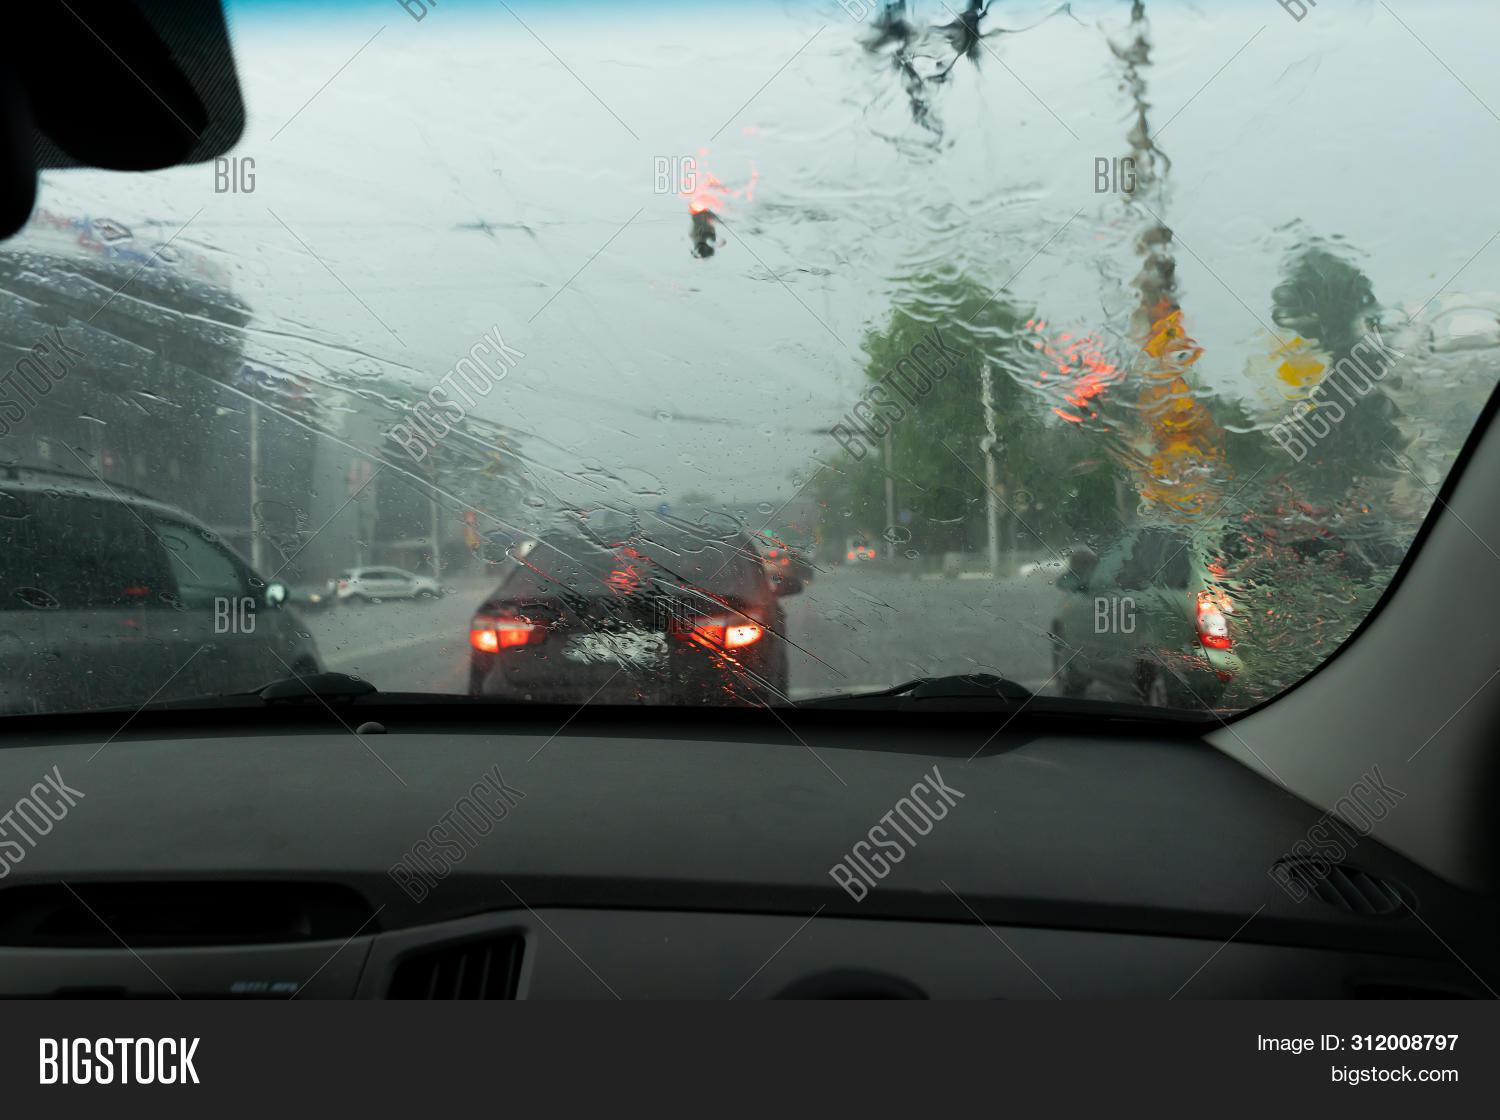What might this image suggest about the driver's experience right now? The driver is likely experiencing limited visibility due to the rain on the windshield, which can be disconcerting. The brake lights from the cars ahead suggest slow-moving or stopped traffic, which may be causing a sense of frustration or impatience for the driver. 